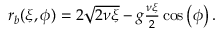Convert formula to latex. <formula><loc_0><loc_0><loc_500><loc_500>\begin{array} { r } { r _ { b } ( \xi , \phi ) = 2 \sqrt { 2 \nu \xi } - g \frac { \nu \xi } { 2 } \cos \left ( \phi \right ) . } \end{array}</formula> 